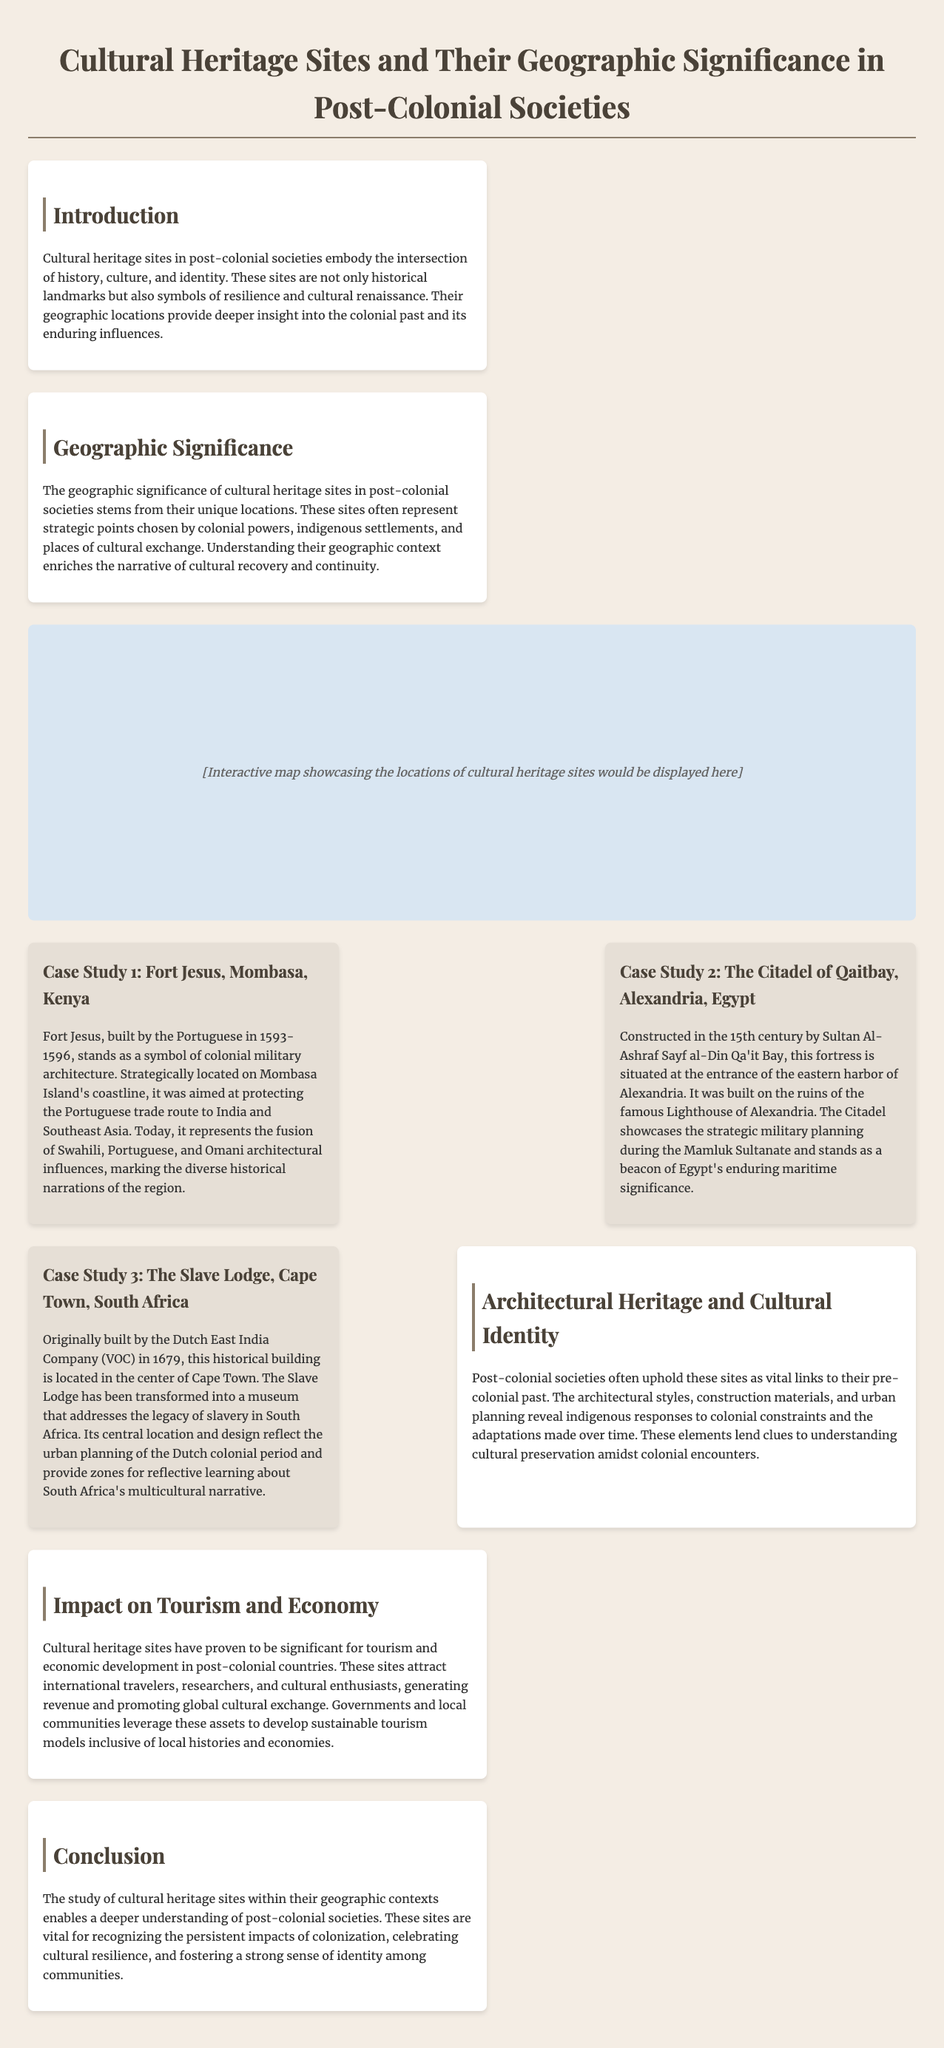What is the primary theme of the infographic? The infographic focuses on cultural heritage sites and their geographic significance in post-colonial societies.
Answer: Cultural heritage sites What year was Fort Jesus built? According to the document, Fort Jesus was constructed between 1593 and 1596.
Answer: 1593-1596 Which fortress was built on the ruins of the Lighthouse of Alexandria? The Citadel of Qaitbay was constructed on the ruins of the famous Lighthouse of Alexandria.
Answer: Citadel of Qaitbay What significant economic benefit do cultural heritage sites provide to post-colonial societies? Cultural heritage sites attract international travelers and generate revenue through tourism and cultural exchange.
Answer: Tourism What architectural influences are present at Fort Jesus? Fort Jesus showcases the fusion of Swahili, Portuguese, and Omani architectural influences.
Answer: Swahili, Portuguese, Omani What is the document's conclusion about cultural heritage sites? The study recognizes the persistent impacts of colonization and celebrates cultural resilience and identity.
Answer: Cultural resilience and identity What type of building is the Slave Lodge? The Slave Lodge is a historical building that has been transformed into a museum addressing the legacy of slavery.
Answer: Museum What impact did colonial powers have on the locations of cultural heritage sites? The locations often represent strategic points chosen by colonial powers and indigenous settlements.
Answer: Strategic points What architectural aspect does the infographic emphasize in post-colonial societies? The infographic emphasizes that architectural styles reveal indigenous responses to colonial constraints.
Answer: Indigenous responses 